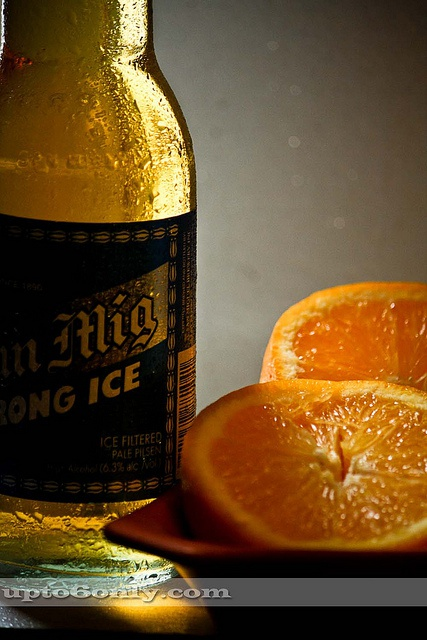Describe the objects in this image and their specific colors. I can see bottle in gray, black, maroon, and olive tones and orange in gray, brown, red, maroon, and orange tones in this image. 